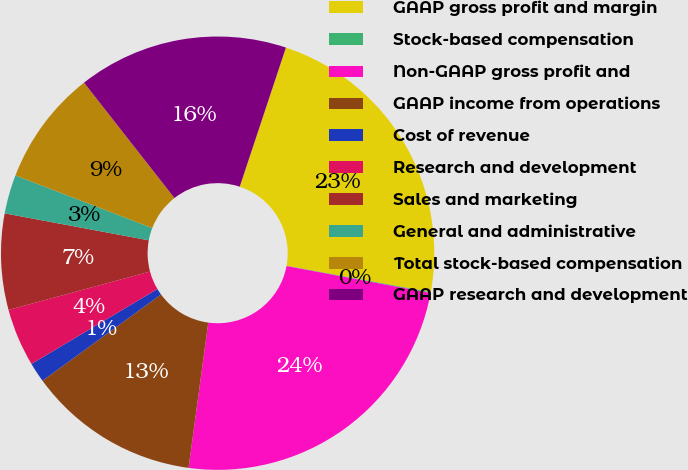<chart> <loc_0><loc_0><loc_500><loc_500><pie_chart><fcel>GAAP gross profit and margin<fcel>Stock-based compensation<fcel>Non-GAAP gross profit and<fcel>GAAP income from operations<fcel>Cost of revenue<fcel>Research and development<fcel>Sales and marketing<fcel>General and administrative<fcel>Total stock-based compensation<fcel>GAAP research and development<nl><fcel>22.78%<fcel>0.06%<fcel>24.2%<fcel>12.84%<fcel>1.48%<fcel>4.32%<fcel>7.16%<fcel>2.9%<fcel>8.58%<fcel>15.68%<nl></chart> 